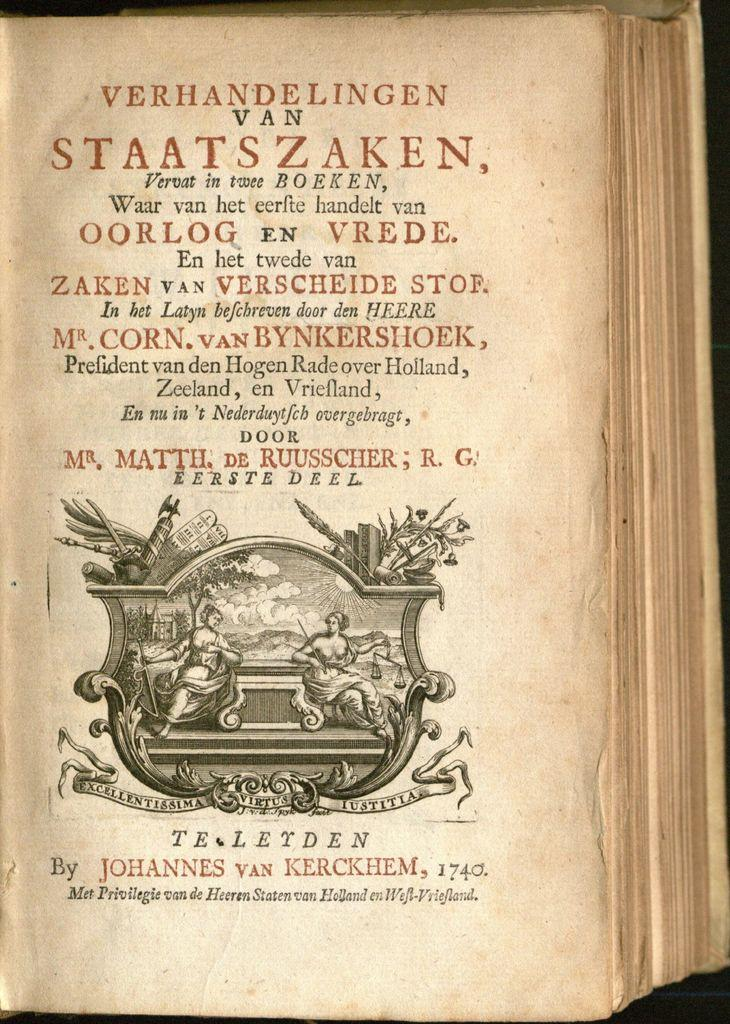Provide a one-sentence caption for the provided image. A single page of an old book by Johannes van kerckhem. 